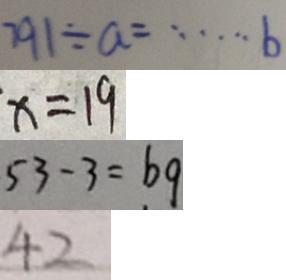Convert formula to latex. <formula><loc_0><loc_0><loc_500><loc_500>7 9 1 \div a = \cdots b 
 x = 1 9 
 5 3 - 3 = b q 
 4 2</formula> 